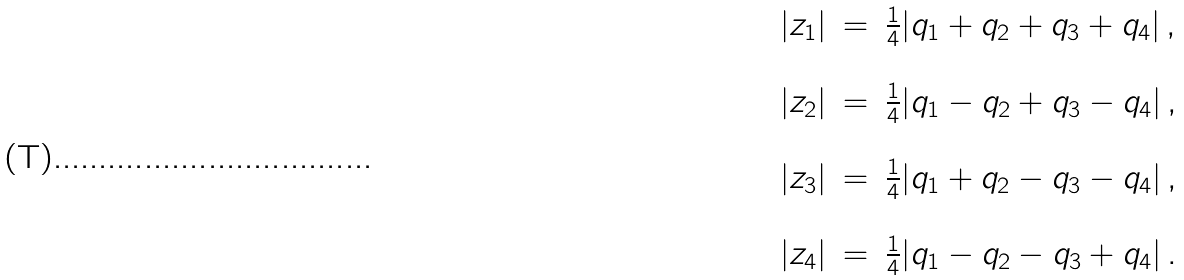<formula> <loc_0><loc_0><loc_500><loc_500>\begin{array} { r c l } | z _ { 1 } | & = & \frac { 1 } { 4 } | q _ { 1 } + q _ { 2 } + q _ { 3 } + q _ { 4 } | \, , \\ & & \\ | z _ { 2 } | & = & \frac { 1 } { 4 } | q _ { 1 } - q _ { 2 } + q _ { 3 } - q _ { 4 } | \, , \\ & & \\ | z _ { 3 } | & = & \frac { 1 } { 4 } | q _ { 1 } + q _ { 2 } - q _ { 3 } - q _ { 4 } | \, , \\ & & \\ | z _ { 4 } | & = & \frac { 1 } { 4 } | q _ { 1 } - q _ { 2 } - q _ { 3 } + q _ { 4 } | \, . \\ & & \\ \end{array}</formula> 